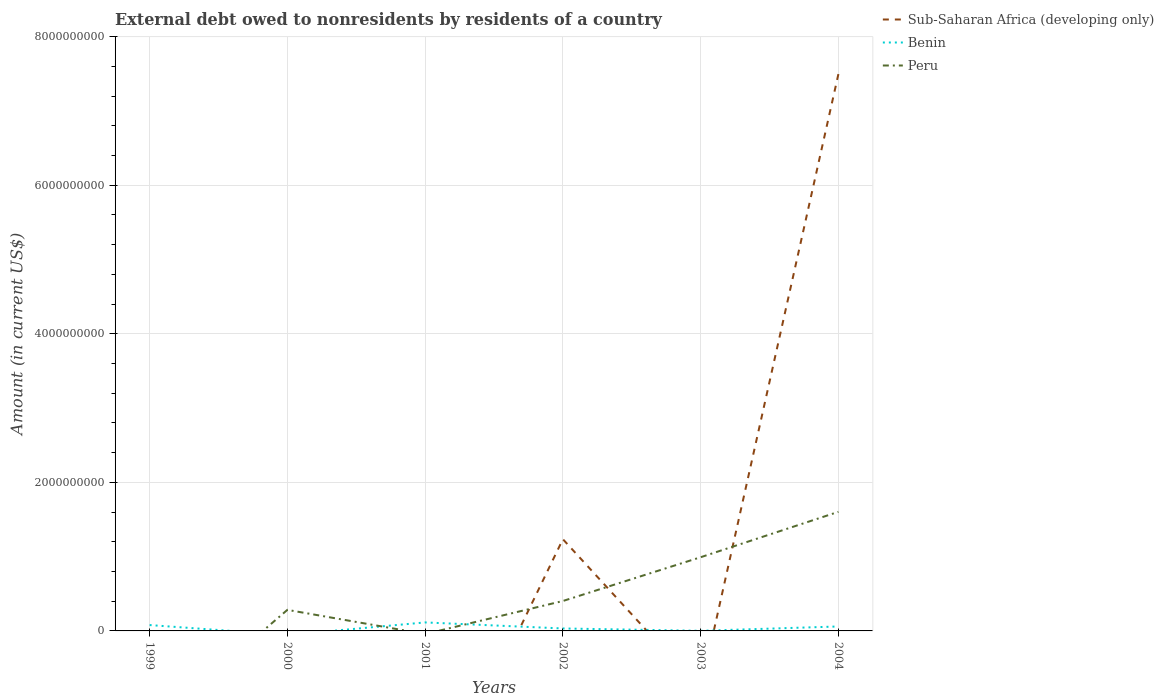How many different coloured lines are there?
Make the answer very short. 3. Does the line corresponding to Peru intersect with the line corresponding to Sub-Saharan Africa (developing only)?
Make the answer very short. Yes. What is the total external debt owed by residents in Benin in the graph?
Provide a succinct answer. 8.14e+07. What is the difference between the highest and the second highest external debt owed by residents in Sub-Saharan Africa (developing only)?
Offer a very short reply. 7.50e+09. How many lines are there?
Your answer should be compact. 3. What is the difference between two consecutive major ticks on the Y-axis?
Keep it short and to the point. 2.00e+09. Are the values on the major ticks of Y-axis written in scientific E-notation?
Offer a very short reply. No. How many legend labels are there?
Offer a terse response. 3. How are the legend labels stacked?
Provide a succinct answer. Vertical. What is the title of the graph?
Give a very brief answer. External debt owed to nonresidents by residents of a country. Does "New Zealand" appear as one of the legend labels in the graph?
Your answer should be compact. No. What is the Amount (in current US$) in Sub-Saharan Africa (developing only) in 1999?
Keep it short and to the point. 0. What is the Amount (in current US$) of Benin in 1999?
Your answer should be very brief. 7.89e+07. What is the Amount (in current US$) in Peru in 1999?
Your response must be concise. 0. What is the Amount (in current US$) of Sub-Saharan Africa (developing only) in 2000?
Your answer should be very brief. 0. What is the Amount (in current US$) of Benin in 2000?
Keep it short and to the point. 0. What is the Amount (in current US$) in Peru in 2000?
Provide a short and direct response. 2.83e+08. What is the Amount (in current US$) of Sub-Saharan Africa (developing only) in 2001?
Give a very brief answer. 0. What is the Amount (in current US$) in Benin in 2001?
Offer a very short reply. 1.14e+08. What is the Amount (in current US$) of Peru in 2001?
Ensure brevity in your answer.  0. What is the Amount (in current US$) of Sub-Saharan Africa (developing only) in 2002?
Keep it short and to the point. 1.23e+09. What is the Amount (in current US$) in Benin in 2002?
Offer a terse response. 3.30e+07. What is the Amount (in current US$) of Peru in 2002?
Ensure brevity in your answer.  4.03e+08. What is the Amount (in current US$) of Benin in 2003?
Offer a very short reply. 1.52e+06. What is the Amount (in current US$) of Peru in 2003?
Your response must be concise. 9.92e+08. What is the Amount (in current US$) in Sub-Saharan Africa (developing only) in 2004?
Make the answer very short. 7.50e+09. What is the Amount (in current US$) of Benin in 2004?
Give a very brief answer. 6.00e+07. What is the Amount (in current US$) of Peru in 2004?
Keep it short and to the point. 1.60e+09. Across all years, what is the maximum Amount (in current US$) of Sub-Saharan Africa (developing only)?
Ensure brevity in your answer.  7.50e+09. Across all years, what is the maximum Amount (in current US$) of Benin?
Provide a succinct answer. 1.14e+08. Across all years, what is the maximum Amount (in current US$) in Peru?
Give a very brief answer. 1.60e+09. Across all years, what is the minimum Amount (in current US$) in Sub-Saharan Africa (developing only)?
Provide a short and direct response. 0. Across all years, what is the minimum Amount (in current US$) in Benin?
Make the answer very short. 0. What is the total Amount (in current US$) of Sub-Saharan Africa (developing only) in the graph?
Give a very brief answer. 8.73e+09. What is the total Amount (in current US$) of Benin in the graph?
Offer a terse response. 2.88e+08. What is the total Amount (in current US$) of Peru in the graph?
Provide a short and direct response. 3.28e+09. What is the difference between the Amount (in current US$) in Benin in 1999 and that in 2001?
Offer a very short reply. -3.55e+07. What is the difference between the Amount (in current US$) of Benin in 1999 and that in 2002?
Keep it short and to the point. 4.59e+07. What is the difference between the Amount (in current US$) in Benin in 1999 and that in 2003?
Provide a short and direct response. 7.74e+07. What is the difference between the Amount (in current US$) in Benin in 1999 and that in 2004?
Keep it short and to the point. 1.89e+07. What is the difference between the Amount (in current US$) in Peru in 2000 and that in 2002?
Keep it short and to the point. -1.19e+08. What is the difference between the Amount (in current US$) of Peru in 2000 and that in 2003?
Provide a short and direct response. -7.09e+08. What is the difference between the Amount (in current US$) of Peru in 2000 and that in 2004?
Ensure brevity in your answer.  -1.32e+09. What is the difference between the Amount (in current US$) in Benin in 2001 and that in 2002?
Provide a short and direct response. 8.14e+07. What is the difference between the Amount (in current US$) in Benin in 2001 and that in 2003?
Make the answer very short. 1.13e+08. What is the difference between the Amount (in current US$) in Benin in 2001 and that in 2004?
Your answer should be very brief. 5.44e+07. What is the difference between the Amount (in current US$) of Benin in 2002 and that in 2003?
Ensure brevity in your answer.  3.15e+07. What is the difference between the Amount (in current US$) in Peru in 2002 and that in 2003?
Provide a short and direct response. -5.89e+08. What is the difference between the Amount (in current US$) of Sub-Saharan Africa (developing only) in 2002 and that in 2004?
Your response must be concise. -6.26e+09. What is the difference between the Amount (in current US$) in Benin in 2002 and that in 2004?
Offer a terse response. -2.70e+07. What is the difference between the Amount (in current US$) in Peru in 2002 and that in 2004?
Your answer should be very brief. -1.20e+09. What is the difference between the Amount (in current US$) in Benin in 2003 and that in 2004?
Give a very brief answer. -5.85e+07. What is the difference between the Amount (in current US$) in Peru in 2003 and that in 2004?
Provide a short and direct response. -6.11e+08. What is the difference between the Amount (in current US$) of Benin in 1999 and the Amount (in current US$) of Peru in 2000?
Ensure brevity in your answer.  -2.04e+08. What is the difference between the Amount (in current US$) of Benin in 1999 and the Amount (in current US$) of Peru in 2002?
Provide a succinct answer. -3.24e+08. What is the difference between the Amount (in current US$) of Benin in 1999 and the Amount (in current US$) of Peru in 2003?
Provide a short and direct response. -9.13e+08. What is the difference between the Amount (in current US$) in Benin in 1999 and the Amount (in current US$) in Peru in 2004?
Ensure brevity in your answer.  -1.52e+09. What is the difference between the Amount (in current US$) of Benin in 2001 and the Amount (in current US$) of Peru in 2002?
Your answer should be compact. -2.88e+08. What is the difference between the Amount (in current US$) in Benin in 2001 and the Amount (in current US$) in Peru in 2003?
Your response must be concise. -8.78e+08. What is the difference between the Amount (in current US$) in Benin in 2001 and the Amount (in current US$) in Peru in 2004?
Your answer should be very brief. -1.49e+09. What is the difference between the Amount (in current US$) of Sub-Saharan Africa (developing only) in 2002 and the Amount (in current US$) of Benin in 2003?
Offer a very short reply. 1.23e+09. What is the difference between the Amount (in current US$) in Sub-Saharan Africa (developing only) in 2002 and the Amount (in current US$) in Peru in 2003?
Keep it short and to the point. 2.43e+08. What is the difference between the Amount (in current US$) in Benin in 2002 and the Amount (in current US$) in Peru in 2003?
Provide a short and direct response. -9.59e+08. What is the difference between the Amount (in current US$) of Sub-Saharan Africa (developing only) in 2002 and the Amount (in current US$) of Benin in 2004?
Ensure brevity in your answer.  1.17e+09. What is the difference between the Amount (in current US$) of Sub-Saharan Africa (developing only) in 2002 and the Amount (in current US$) of Peru in 2004?
Make the answer very short. -3.68e+08. What is the difference between the Amount (in current US$) of Benin in 2002 and the Amount (in current US$) of Peru in 2004?
Keep it short and to the point. -1.57e+09. What is the difference between the Amount (in current US$) in Benin in 2003 and the Amount (in current US$) in Peru in 2004?
Ensure brevity in your answer.  -1.60e+09. What is the average Amount (in current US$) of Sub-Saharan Africa (developing only) per year?
Provide a succinct answer. 1.46e+09. What is the average Amount (in current US$) in Benin per year?
Provide a short and direct response. 4.80e+07. What is the average Amount (in current US$) of Peru per year?
Your response must be concise. 5.47e+08. In the year 2002, what is the difference between the Amount (in current US$) in Sub-Saharan Africa (developing only) and Amount (in current US$) in Benin?
Your response must be concise. 1.20e+09. In the year 2002, what is the difference between the Amount (in current US$) of Sub-Saharan Africa (developing only) and Amount (in current US$) of Peru?
Provide a short and direct response. 8.32e+08. In the year 2002, what is the difference between the Amount (in current US$) in Benin and Amount (in current US$) in Peru?
Ensure brevity in your answer.  -3.70e+08. In the year 2003, what is the difference between the Amount (in current US$) of Benin and Amount (in current US$) of Peru?
Offer a very short reply. -9.90e+08. In the year 2004, what is the difference between the Amount (in current US$) in Sub-Saharan Africa (developing only) and Amount (in current US$) in Benin?
Provide a succinct answer. 7.44e+09. In the year 2004, what is the difference between the Amount (in current US$) of Sub-Saharan Africa (developing only) and Amount (in current US$) of Peru?
Your answer should be very brief. 5.89e+09. In the year 2004, what is the difference between the Amount (in current US$) in Benin and Amount (in current US$) in Peru?
Offer a terse response. -1.54e+09. What is the ratio of the Amount (in current US$) of Benin in 1999 to that in 2001?
Provide a succinct answer. 0.69. What is the ratio of the Amount (in current US$) in Benin in 1999 to that in 2002?
Provide a short and direct response. 2.39. What is the ratio of the Amount (in current US$) of Benin in 1999 to that in 2003?
Make the answer very short. 51.92. What is the ratio of the Amount (in current US$) of Benin in 1999 to that in 2004?
Ensure brevity in your answer.  1.31. What is the ratio of the Amount (in current US$) of Peru in 2000 to that in 2002?
Provide a succinct answer. 0.7. What is the ratio of the Amount (in current US$) in Peru in 2000 to that in 2003?
Ensure brevity in your answer.  0.29. What is the ratio of the Amount (in current US$) in Peru in 2000 to that in 2004?
Make the answer very short. 0.18. What is the ratio of the Amount (in current US$) of Benin in 2001 to that in 2002?
Offer a terse response. 3.47. What is the ratio of the Amount (in current US$) in Benin in 2001 to that in 2003?
Your answer should be compact. 75.31. What is the ratio of the Amount (in current US$) in Benin in 2001 to that in 2004?
Provide a succinct answer. 1.91. What is the ratio of the Amount (in current US$) in Benin in 2002 to that in 2003?
Make the answer very short. 21.73. What is the ratio of the Amount (in current US$) in Peru in 2002 to that in 2003?
Ensure brevity in your answer.  0.41. What is the ratio of the Amount (in current US$) of Sub-Saharan Africa (developing only) in 2002 to that in 2004?
Your answer should be compact. 0.16. What is the ratio of the Amount (in current US$) of Benin in 2002 to that in 2004?
Offer a very short reply. 0.55. What is the ratio of the Amount (in current US$) of Peru in 2002 to that in 2004?
Your answer should be very brief. 0.25. What is the ratio of the Amount (in current US$) of Benin in 2003 to that in 2004?
Make the answer very short. 0.03. What is the ratio of the Amount (in current US$) in Peru in 2003 to that in 2004?
Keep it short and to the point. 0.62. What is the difference between the highest and the second highest Amount (in current US$) of Benin?
Give a very brief answer. 3.55e+07. What is the difference between the highest and the second highest Amount (in current US$) of Peru?
Provide a succinct answer. 6.11e+08. What is the difference between the highest and the lowest Amount (in current US$) of Sub-Saharan Africa (developing only)?
Ensure brevity in your answer.  7.50e+09. What is the difference between the highest and the lowest Amount (in current US$) of Benin?
Your answer should be compact. 1.14e+08. What is the difference between the highest and the lowest Amount (in current US$) in Peru?
Keep it short and to the point. 1.60e+09. 